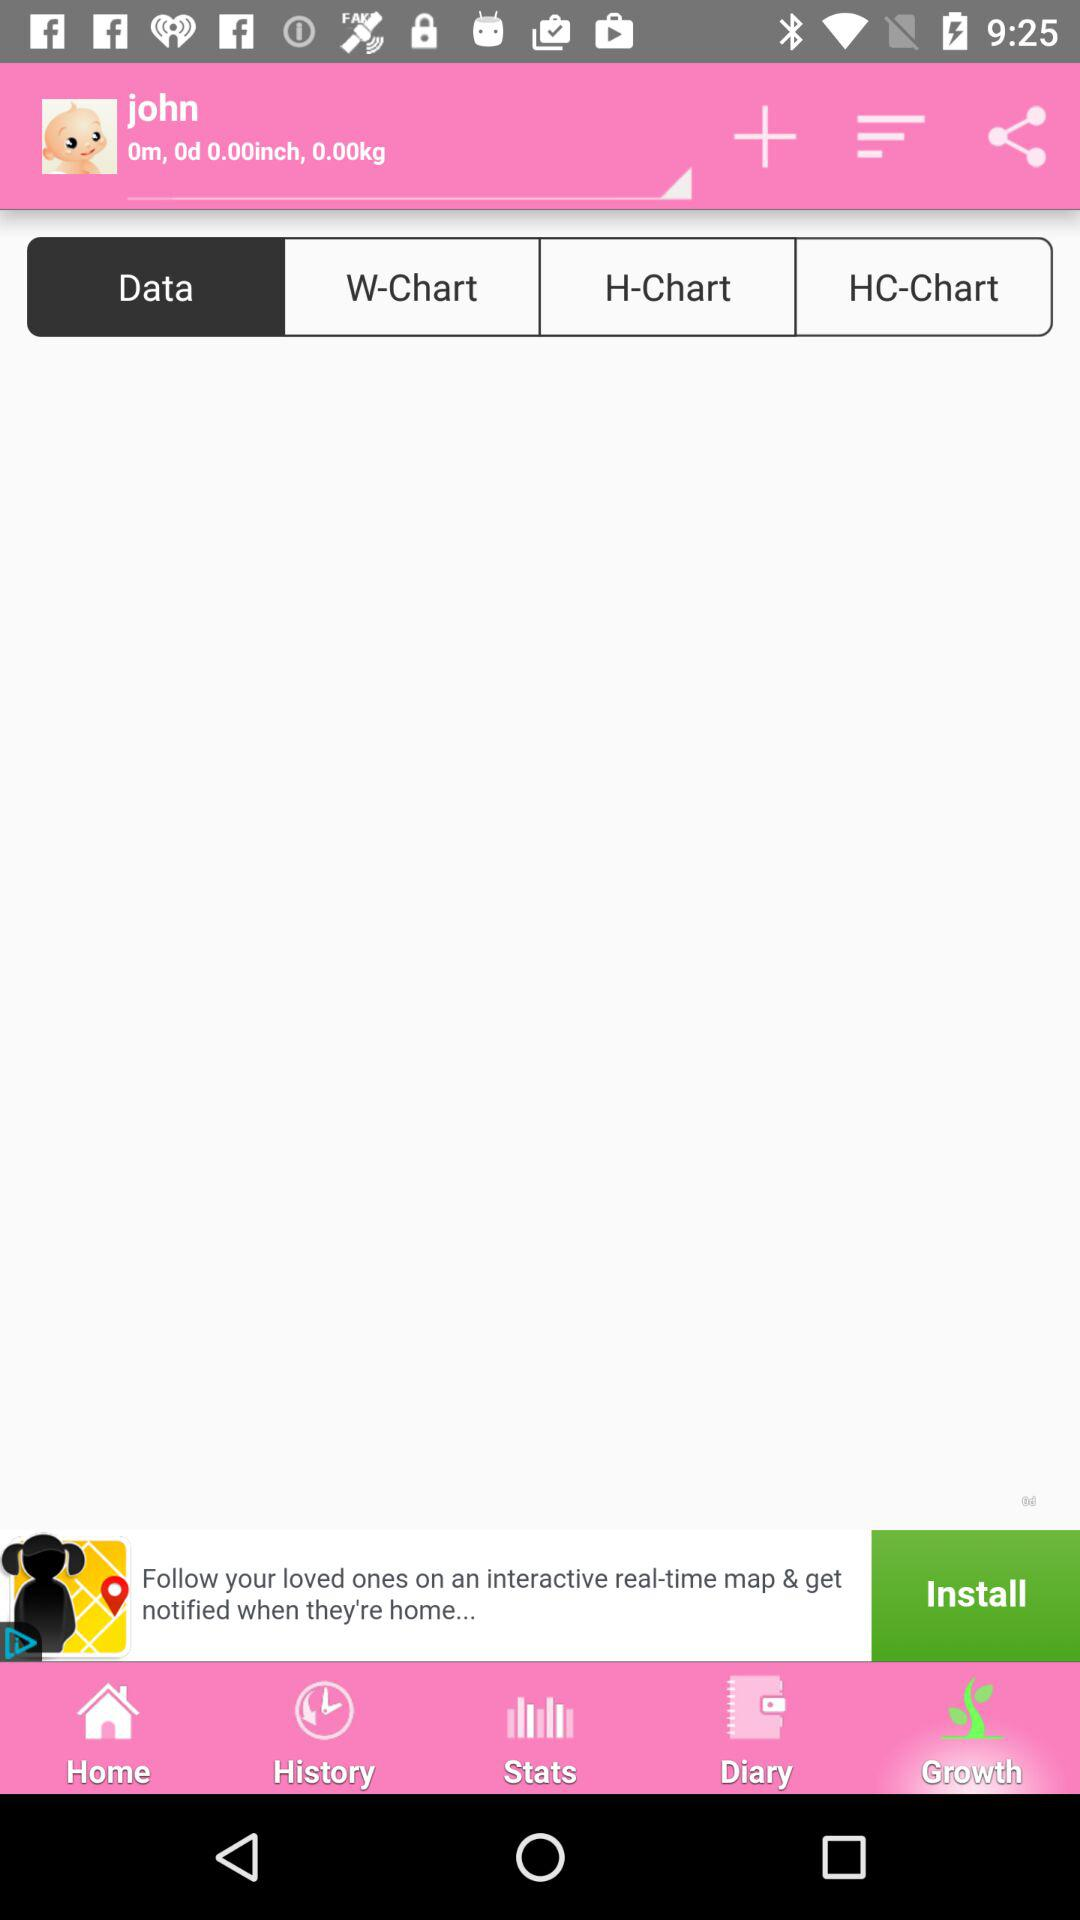What is the selected tab? The selected tabs are "Growth" and "Data". 